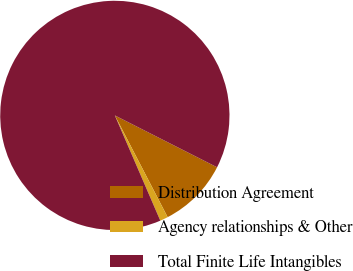Convert chart. <chart><loc_0><loc_0><loc_500><loc_500><pie_chart><fcel>Distribution Agreement<fcel>Agency relationships & Other<fcel>Total Finite Life Intangibles<nl><fcel>9.91%<fcel>1.13%<fcel>88.96%<nl></chart> 